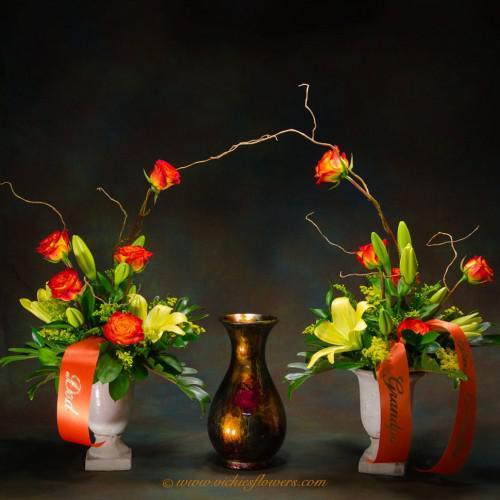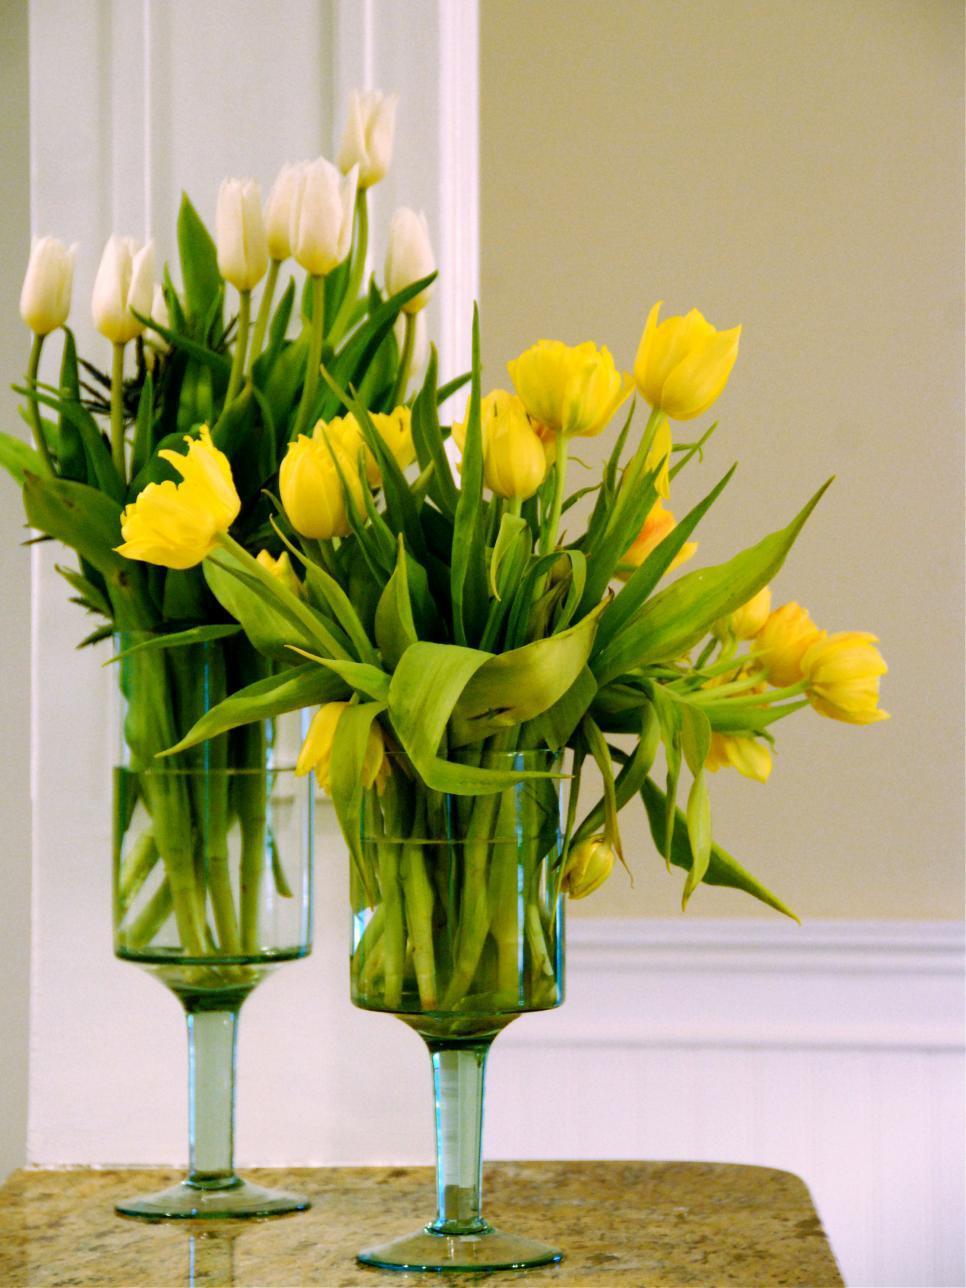The first image is the image on the left, the second image is the image on the right. Given the left and right images, does the statement "Yellow flowers sit in some of the vases." hold true? Answer yes or no. Yes. 